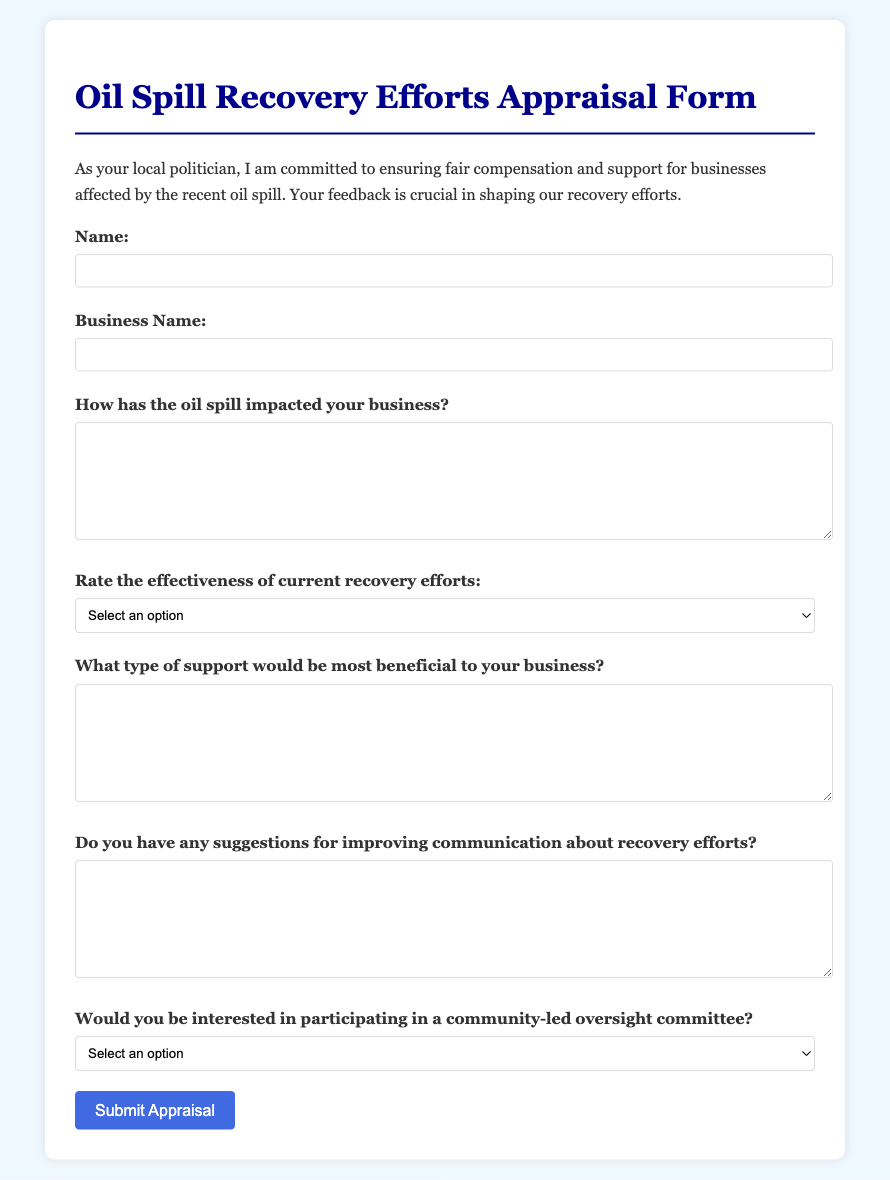What is the title of the document? The title, as mentioned in the document, summarizes the purpose of the form.
Answer: Oil Spill Recovery Efforts Appraisal Form What is the background color of the form? The background color is specified in the style section of the document.
Answer: #f0f8ff What type of feedback is being solicited through the form? The form explicitly states the type of feedback being sought from the respondents.
Answer: Community feedback What is the rating scale for the effectiveness of recovery efforts? The scale is outlined in the select dropdown options of the form.
Answer: 1 to 5 What type of support is being asked about for businesses? The form requests specific kinds of assistance that could benefit businesses.
Answer: Support type Would respondents be interested in joining a community-led committee? This question aims to engage respondents in community initiatives related to recovery efforts.
Answer: Yes, No, Maybe How many form fields are listed for response? The document includes a total number of fields for the respondents to fill in.
Answer: 6 fields What is the color of the button used to submit the form? The button's background color is defined in the styling of the document.
Answer: #4169e1 What is the first field that respondents need to fill out? The form's structure dictates the initial field for personal information.
Answer: Name 